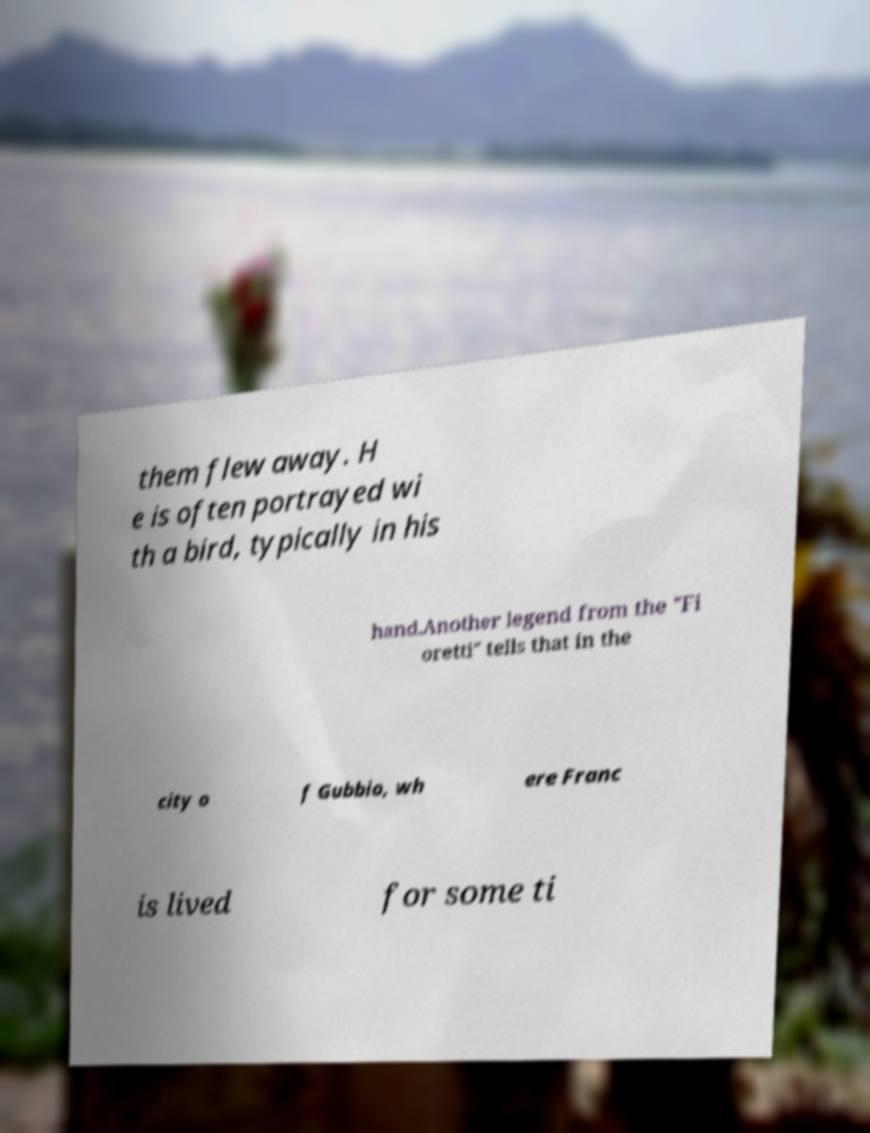For documentation purposes, I need the text within this image transcribed. Could you provide that? them flew away. H e is often portrayed wi th a bird, typically in his hand.Another legend from the "Fi oretti" tells that in the city o f Gubbio, wh ere Franc is lived for some ti 